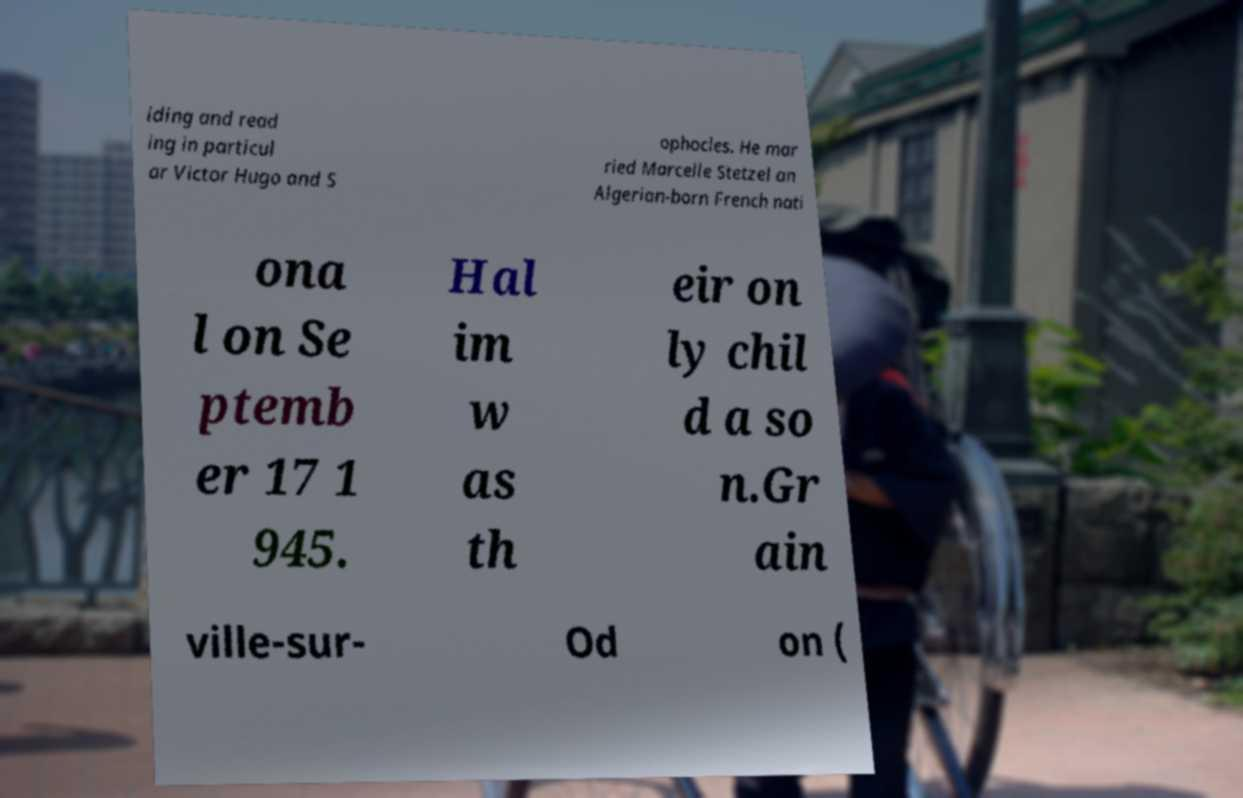I need the written content from this picture converted into text. Can you do that? iding and read ing in particul ar Victor Hugo and S ophocles. He mar ried Marcelle Stetzel an Algerian-born French nati ona l on Se ptemb er 17 1 945. Hal im w as th eir on ly chil d a so n.Gr ain ville-sur- Od on ( 